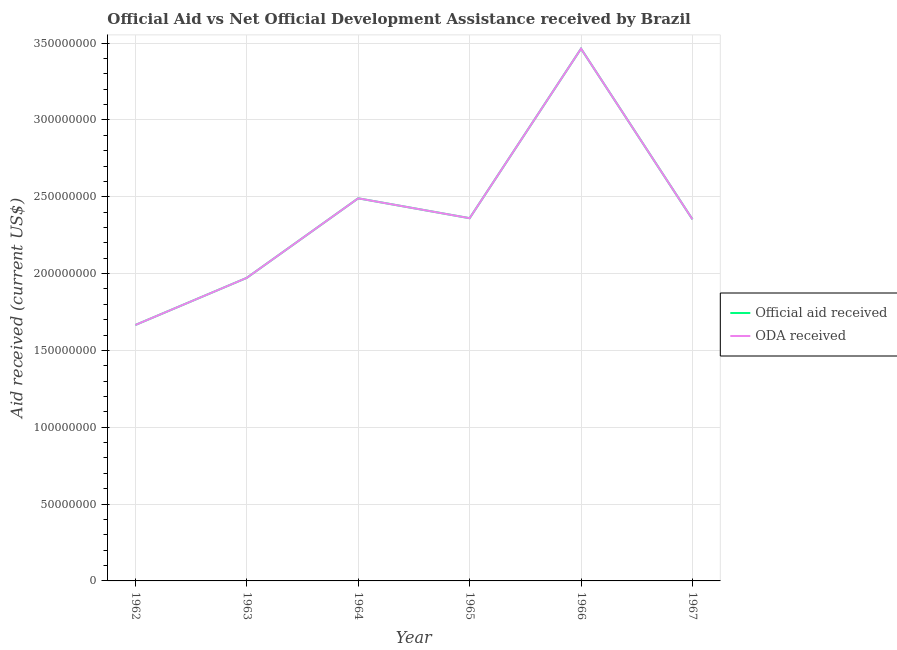Does the line corresponding to official aid received intersect with the line corresponding to oda received?
Your answer should be very brief. Yes. What is the official aid received in 1966?
Your answer should be very brief. 3.46e+08. Across all years, what is the maximum official aid received?
Give a very brief answer. 3.46e+08. Across all years, what is the minimum oda received?
Your answer should be very brief. 1.67e+08. In which year was the official aid received maximum?
Offer a terse response. 1966. In which year was the oda received minimum?
Provide a short and direct response. 1962. What is the total official aid received in the graph?
Ensure brevity in your answer.  1.43e+09. What is the difference between the oda received in 1964 and that in 1965?
Provide a short and direct response. 1.29e+07. What is the difference between the oda received in 1967 and the official aid received in 1965?
Ensure brevity in your answer.  -7.50e+05. What is the average oda received per year?
Your answer should be compact. 2.38e+08. In the year 1966, what is the difference between the official aid received and oda received?
Offer a very short reply. 0. What is the ratio of the official aid received in 1963 to that in 1966?
Your answer should be compact. 0.57. Is the official aid received in 1963 less than that in 1966?
Your answer should be very brief. Yes. Is the difference between the official aid received in 1962 and 1963 greater than the difference between the oda received in 1962 and 1963?
Ensure brevity in your answer.  No. What is the difference between the highest and the second highest oda received?
Provide a succinct answer. 9.74e+07. What is the difference between the highest and the lowest oda received?
Provide a succinct answer. 1.80e+08. In how many years, is the official aid received greater than the average official aid received taken over all years?
Provide a short and direct response. 2. Is the sum of the official aid received in 1962 and 1966 greater than the maximum oda received across all years?
Make the answer very short. Yes. Does the oda received monotonically increase over the years?
Your answer should be very brief. No. Is the oda received strictly greater than the official aid received over the years?
Give a very brief answer. No. How many lines are there?
Offer a terse response. 2. How many years are there in the graph?
Offer a terse response. 6. Are the values on the major ticks of Y-axis written in scientific E-notation?
Provide a short and direct response. No. What is the title of the graph?
Your answer should be compact. Official Aid vs Net Official Development Assistance received by Brazil . What is the label or title of the X-axis?
Keep it short and to the point. Year. What is the label or title of the Y-axis?
Ensure brevity in your answer.  Aid received (current US$). What is the Aid received (current US$) in Official aid received in 1962?
Provide a succinct answer. 1.67e+08. What is the Aid received (current US$) in ODA received in 1962?
Offer a terse response. 1.67e+08. What is the Aid received (current US$) in Official aid received in 1963?
Your answer should be very brief. 1.97e+08. What is the Aid received (current US$) in ODA received in 1963?
Keep it short and to the point. 1.97e+08. What is the Aid received (current US$) in Official aid received in 1964?
Give a very brief answer. 2.49e+08. What is the Aid received (current US$) in ODA received in 1964?
Keep it short and to the point. 2.49e+08. What is the Aid received (current US$) of Official aid received in 1965?
Your response must be concise. 2.36e+08. What is the Aid received (current US$) in ODA received in 1965?
Make the answer very short. 2.36e+08. What is the Aid received (current US$) in Official aid received in 1966?
Ensure brevity in your answer.  3.46e+08. What is the Aid received (current US$) of ODA received in 1966?
Offer a terse response. 3.46e+08. What is the Aid received (current US$) in Official aid received in 1967?
Your answer should be very brief. 2.35e+08. What is the Aid received (current US$) of ODA received in 1967?
Make the answer very short. 2.35e+08. Across all years, what is the maximum Aid received (current US$) of Official aid received?
Keep it short and to the point. 3.46e+08. Across all years, what is the maximum Aid received (current US$) of ODA received?
Keep it short and to the point. 3.46e+08. Across all years, what is the minimum Aid received (current US$) of Official aid received?
Make the answer very short. 1.67e+08. Across all years, what is the minimum Aid received (current US$) in ODA received?
Keep it short and to the point. 1.67e+08. What is the total Aid received (current US$) in Official aid received in the graph?
Your response must be concise. 1.43e+09. What is the total Aid received (current US$) of ODA received in the graph?
Keep it short and to the point. 1.43e+09. What is the difference between the Aid received (current US$) of Official aid received in 1962 and that in 1963?
Your answer should be compact. -3.07e+07. What is the difference between the Aid received (current US$) of ODA received in 1962 and that in 1963?
Provide a short and direct response. -3.07e+07. What is the difference between the Aid received (current US$) in Official aid received in 1962 and that in 1964?
Offer a terse response. -8.24e+07. What is the difference between the Aid received (current US$) of ODA received in 1962 and that in 1964?
Offer a terse response. -8.24e+07. What is the difference between the Aid received (current US$) in Official aid received in 1962 and that in 1965?
Ensure brevity in your answer.  -6.95e+07. What is the difference between the Aid received (current US$) of ODA received in 1962 and that in 1965?
Your answer should be very brief. -6.95e+07. What is the difference between the Aid received (current US$) of Official aid received in 1962 and that in 1966?
Provide a succinct answer. -1.80e+08. What is the difference between the Aid received (current US$) in ODA received in 1962 and that in 1966?
Provide a succinct answer. -1.80e+08. What is the difference between the Aid received (current US$) of Official aid received in 1962 and that in 1967?
Provide a short and direct response. -6.88e+07. What is the difference between the Aid received (current US$) in ODA received in 1962 and that in 1967?
Your answer should be very brief. -6.88e+07. What is the difference between the Aid received (current US$) in Official aid received in 1963 and that in 1964?
Provide a short and direct response. -5.18e+07. What is the difference between the Aid received (current US$) of ODA received in 1963 and that in 1964?
Your answer should be compact. -5.18e+07. What is the difference between the Aid received (current US$) in Official aid received in 1963 and that in 1965?
Your answer should be compact. -3.88e+07. What is the difference between the Aid received (current US$) in ODA received in 1963 and that in 1965?
Your answer should be compact. -3.88e+07. What is the difference between the Aid received (current US$) of Official aid received in 1963 and that in 1966?
Your response must be concise. -1.49e+08. What is the difference between the Aid received (current US$) of ODA received in 1963 and that in 1966?
Provide a short and direct response. -1.49e+08. What is the difference between the Aid received (current US$) in Official aid received in 1963 and that in 1967?
Your answer should be compact. -3.81e+07. What is the difference between the Aid received (current US$) in ODA received in 1963 and that in 1967?
Make the answer very short. -3.81e+07. What is the difference between the Aid received (current US$) of Official aid received in 1964 and that in 1965?
Provide a succinct answer. 1.29e+07. What is the difference between the Aid received (current US$) of ODA received in 1964 and that in 1965?
Offer a terse response. 1.29e+07. What is the difference between the Aid received (current US$) in Official aid received in 1964 and that in 1966?
Your answer should be very brief. -9.74e+07. What is the difference between the Aid received (current US$) in ODA received in 1964 and that in 1966?
Your response must be concise. -9.74e+07. What is the difference between the Aid received (current US$) in Official aid received in 1964 and that in 1967?
Your response must be concise. 1.37e+07. What is the difference between the Aid received (current US$) of ODA received in 1964 and that in 1967?
Make the answer very short. 1.37e+07. What is the difference between the Aid received (current US$) in Official aid received in 1965 and that in 1966?
Make the answer very short. -1.10e+08. What is the difference between the Aid received (current US$) of ODA received in 1965 and that in 1966?
Offer a very short reply. -1.10e+08. What is the difference between the Aid received (current US$) of Official aid received in 1965 and that in 1967?
Offer a terse response. 7.50e+05. What is the difference between the Aid received (current US$) in ODA received in 1965 and that in 1967?
Make the answer very short. 7.50e+05. What is the difference between the Aid received (current US$) in Official aid received in 1966 and that in 1967?
Ensure brevity in your answer.  1.11e+08. What is the difference between the Aid received (current US$) in ODA received in 1966 and that in 1967?
Your answer should be compact. 1.11e+08. What is the difference between the Aid received (current US$) in Official aid received in 1962 and the Aid received (current US$) in ODA received in 1963?
Your answer should be very brief. -3.07e+07. What is the difference between the Aid received (current US$) in Official aid received in 1962 and the Aid received (current US$) in ODA received in 1964?
Your answer should be compact. -8.24e+07. What is the difference between the Aid received (current US$) of Official aid received in 1962 and the Aid received (current US$) of ODA received in 1965?
Offer a terse response. -6.95e+07. What is the difference between the Aid received (current US$) in Official aid received in 1962 and the Aid received (current US$) in ODA received in 1966?
Provide a succinct answer. -1.80e+08. What is the difference between the Aid received (current US$) of Official aid received in 1962 and the Aid received (current US$) of ODA received in 1967?
Your answer should be very brief. -6.88e+07. What is the difference between the Aid received (current US$) in Official aid received in 1963 and the Aid received (current US$) in ODA received in 1964?
Make the answer very short. -5.18e+07. What is the difference between the Aid received (current US$) of Official aid received in 1963 and the Aid received (current US$) of ODA received in 1965?
Give a very brief answer. -3.88e+07. What is the difference between the Aid received (current US$) in Official aid received in 1963 and the Aid received (current US$) in ODA received in 1966?
Give a very brief answer. -1.49e+08. What is the difference between the Aid received (current US$) of Official aid received in 1963 and the Aid received (current US$) of ODA received in 1967?
Ensure brevity in your answer.  -3.81e+07. What is the difference between the Aid received (current US$) in Official aid received in 1964 and the Aid received (current US$) in ODA received in 1965?
Give a very brief answer. 1.29e+07. What is the difference between the Aid received (current US$) in Official aid received in 1964 and the Aid received (current US$) in ODA received in 1966?
Provide a succinct answer. -9.74e+07. What is the difference between the Aid received (current US$) in Official aid received in 1964 and the Aid received (current US$) in ODA received in 1967?
Your answer should be compact. 1.37e+07. What is the difference between the Aid received (current US$) of Official aid received in 1965 and the Aid received (current US$) of ODA received in 1966?
Your response must be concise. -1.10e+08. What is the difference between the Aid received (current US$) in Official aid received in 1965 and the Aid received (current US$) in ODA received in 1967?
Keep it short and to the point. 7.50e+05. What is the difference between the Aid received (current US$) of Official aid received in 1966 and the Aid received (current US$) of ODA received in 1967?
Provide a short and direct response. 1.11e+08. What is the average Aid received (current US$) in Official aid received per year?
Provide a short and direct response. 2.38e+08. What is the average Aid received (current US$) of ODA received per year?
Make the answer very short. 2.38e+08. In the year 1963, what is the difference between the Aid received (current US$) of Official aid received and Aid received (current US$) of ODA received?
Provide a short and direct response. 0. In the year 1964, what is the difference between the Aid received (current US$) in Official aid received and Aid received (current US$) in ODA received?
Ensure brevity in your answer.  0. In the year 1967, what is the difference between the Aid received (current US$) in Official aid received and Aid received (current US$) in ODA received?
Make the answer very short. 0. What is the ratio of the Aid received (current US$) in Official aid received in 1962 to that in 1963?
Provide a succinct answer. 0.84. What is the ratio of the Aid received (current US$) of ODA received in 1962 to that in 1963?
Offer a terse response. 0.84. What is the ratio of the Aid received (current US$) in Official aid received in 1962 to that in 1964?
Your answer should be compact. 0.67. What is the ratio of the Aid received (current US$) in ODA received in 1962 to that in 1964?
Keep it short and to the point. 0.67. What is the ratio of the Aid received (current US$) of Official aid received in 1962 to that in 1965?
Give a very brief answer. 0.71. What is the ratio of the Aid received (current US$) of ODA received in 1962 to that in 1965?
Ensure brevity in your answer.  0.71. What is the ratio of the Aid received (current US$) of Official aid received in 1962 to that in 1966?
Your response must be concise. 0.48. What is the ratio of the Aid received (current US$) in ODA received in 1962 to that in 1966?
Your answer should be compact. 0.48. What is the ratio of the Aid received (current US$) of Official aid received in 1962 to that in 1967?
Your answer should be very brief. 0.71. What is the ratio of the Aid received (current US$) of ODA received in 1962 to that in 1967?
Your answer should be compact. 0.71. What is the ratio of the Aid received (current US$) in Official aid received in 1963 to that in 1964?
Offer a terse response. 0.79. What is the ratio of the Aid received (current US$) in ODA received in 1963 to that in 1964?
Keep it short and to the point. 0.79. What is the ratio of the Aid received (current US$) in Official aid received in 1963 to that in 1965?
Offer a very short reply. 0.84. What is the ratio of the Aid received (current US$) in ODA received in 1963 to that in 1965?
Offer a very short reply. 0.84. What is the ratio of the Aid received (current US$) in Official aid received in 1963 to that in 1966?
Offer a very short reply. 0.57. What is the ratio of the Aid received (current US$) in ODA received in 1963 to that in 1966?
Your response must be concise. 0.57. What is the ratio of the Aid received (current US$) in Official aid received in 1963 to that in 1967?
Your answer should be very brief. 0.84. What is the ratio of the Aid received (current US$) in ODA received in 1963 to that in 1967?
Your answer should be very brief. 0.84. What is the ratio of the Aid received (current US$) in Official aid received in 1964 to that in 1965?
Give a very brief answer. 1.05. What is the ratio of the Aid received (current US$) of ODA received in 1964 to that in 1965?
Your response must be concise. 1.05. What is the ratio of the Aid received (current US$) in Official aid received in 1964 to that in 1966?
Your answer should be compact. 0.72. What is the ratio of the Aid received (current US$) in ODA received in 1964 to that in 1966?
Make the answer very short. 0.72. What is the ratio of the Aid received (current US$) in Official aid received in 1964 to that in 1967?
Ensure brevity in your answer.  1.06. What is the ratio of the Aid received (current US$) in ODA received in 1964 to that in 1967?
Your answer should be very brief. 1.06. What is the ratio of the Aid received (current US$) of Official aid received in 1965 to that in 1966?
Provide a short and direct response. 0.68. What is the ratio of the Aid received (current US$) of ODA received in 1965 to that in 1966?
Give a very brief answer. 0.68. What is the ratio of the Aid received (current US$) of Official aid received in 1966 to that in 1967?
Your response must be concise. 1.47. What is the ratio of the Aid received (current US$) in ODA received in 1966 to that in 1967?
Keep it short and to the point. 1.47. What is the difference between the highest and the second highest Aid received (current US$) in Official aid received?
Make the answer very short. 9.74e+07. What is the difference between the highest and the second highest Aid received (current US$) of ODA received?
Provide a short and direct response. 9.74e+07. What is the difference between the highest and the lowest Aid received (current US$) in Official aid received?
Provide a succinct answer. 1.80e+08. What is the difference between the highest and the lowest Aid received (current US$) of ODA received?
Keep it short and to the point. 1.80e+08. 